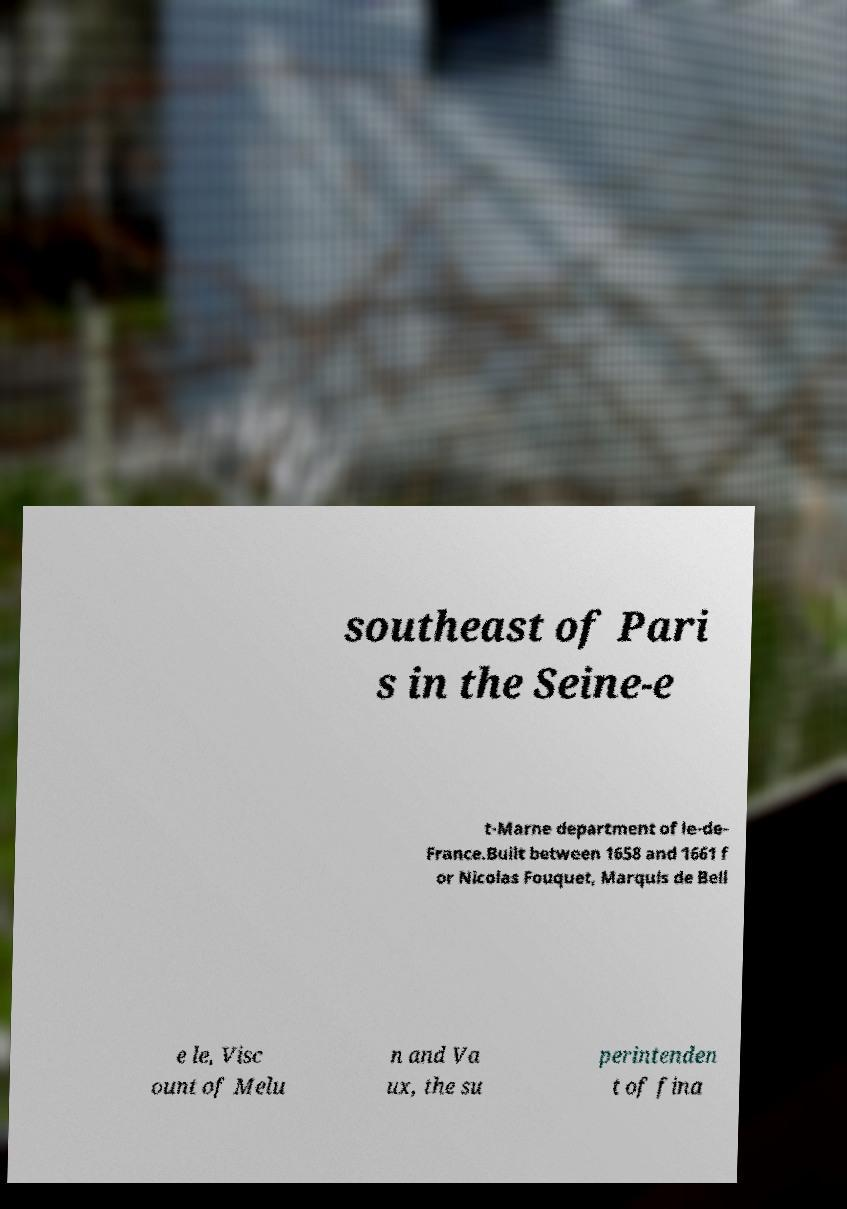What messages or text are displayed in this image? I need them in a readable, typed format. southeast of Pari s in the Seine-e t-Marne department of le-de- France.Built between 1658 and 1661 f or Nicolas Fouquet, Marquis de Bell e le, Visc ount of Melu n and Va ux, the su perintenden t of fina 